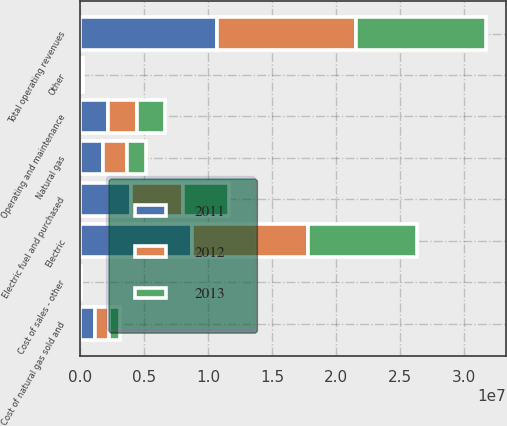Convert chart. <chart><loc_0><loc_0><loc_500><loc_500><stacked_bar_chart><ecel><fcel>Electric<fcel>Natural gas<fcel>Other<fcel>Total operating revenues<fcel>Electric fuel and purchased<fcel>Cost of natural gas sold and<fcel>Cost of sales - other<fcel>Operating and maintenance<nl><fcel>2012<fcel>9.03404e+06<fcel>1.80468e+06<fcel>76198<fcel>1.09149e+07<fcel>4.01867e+06<fcel>1.08275e+06<fcel>33323<fcel>2.27353e+06<nl><fcel>2013<fcel>8.5173e+06<fcel>1.53737e+06<fcel>73553<fcel>1.01282e+07<fcel>3.62394e+06<fcel>880939<fcel>29067<fcel>2.1761e+06<nl><fcel>2011<fcel>8.76659e+06<fcel>1.81193e+06<fcel>76251<fcel>1.06548e+07<fcel>3.99179e+06<fcel>1.16389e+06<fcel>30391<fcel>2.14029e+06<nl></chart> 